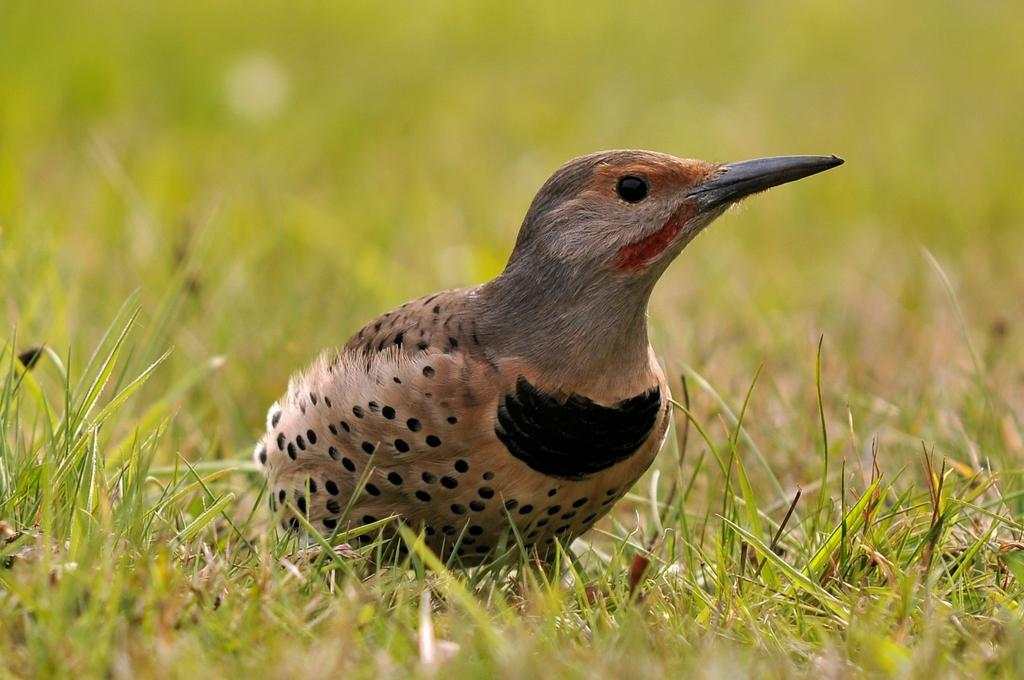What type of animal can be seen in the image? There is a bird in the image. Where is the bird located? The bird is on the grass. Who won the competition involving the bird in the image? There is no competition involving the bird in the image. 